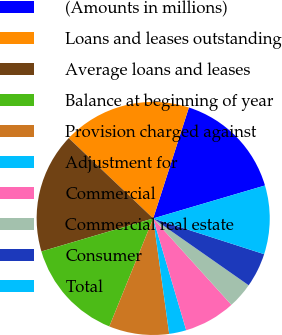Convert chart. <chart><loc_0><loc_0><loc_500><loc_500><pie_chart><fcel>(Amounts in millions)<fcel>Loans and leases outstanding<fcel>Average loans and leases<fcel>Balance at beginning of year<fcel>Provision charged against<fcel>Adjustment for<fcel>Commercial<fcel>Commercial real estate<fcel>Consumer<fcel>Total<nl><fcel>15.48%<fcel>17.86%<fcel>16.67%<fcel>14.29%<fcel>8.33%<fcel>2.38%<fcel>7.14%<fcel>3.57%<fcel>4.76%<fcel>9.52%<nl></chart> 